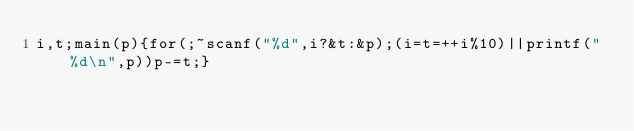Convert code to text. <code><loc_0><loc_0><loc_500><loc_500><_C_>i,t;main(p){for(;~scanf("%d",i?&t:&p);(i=t=++i%10)||printf("%d\n",p))p-=t;}</code> 